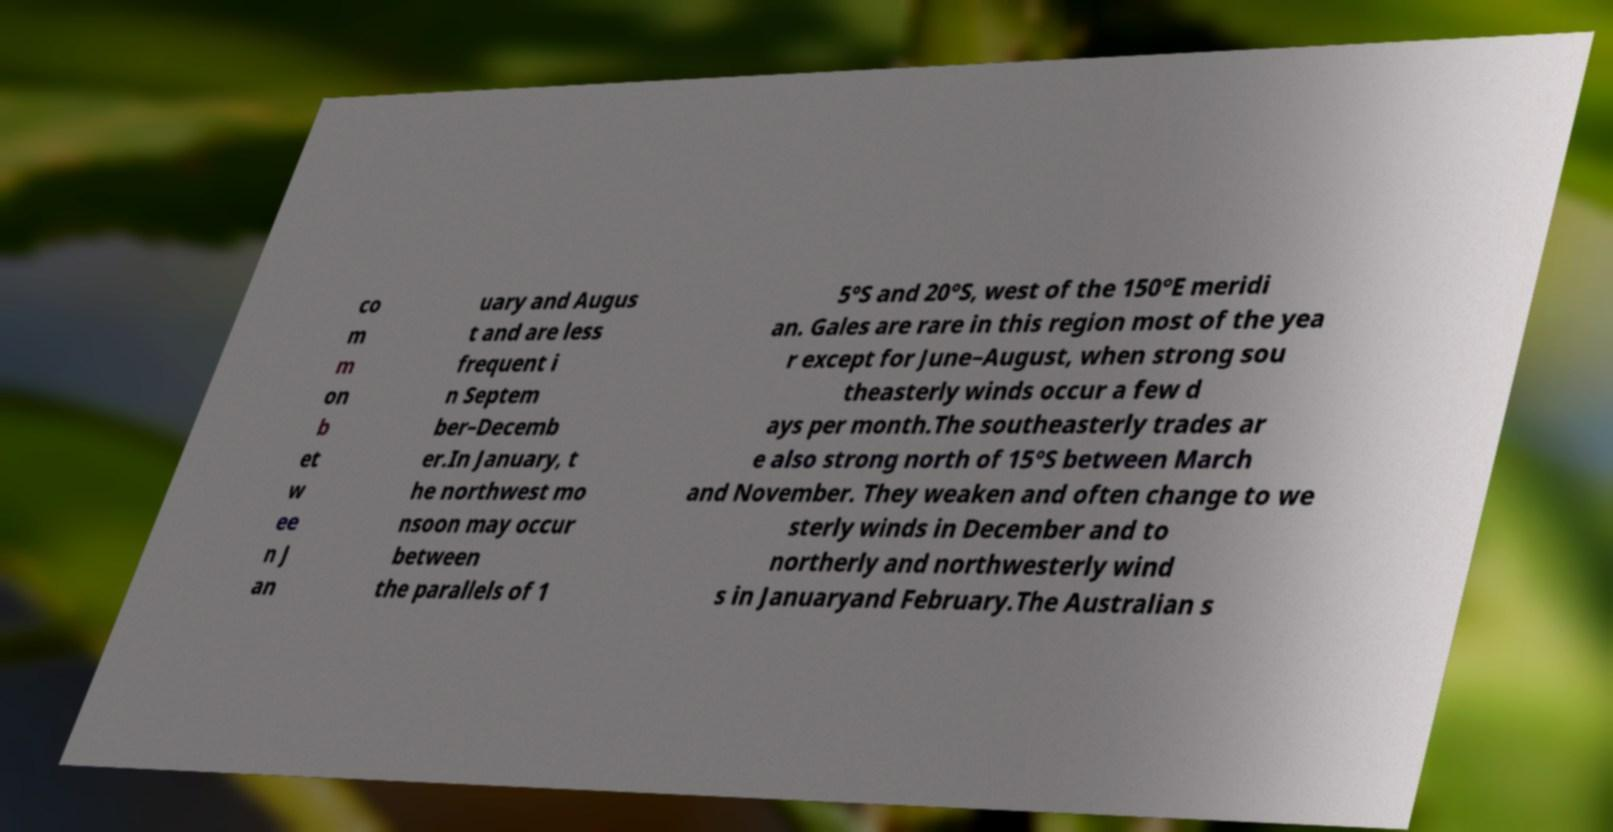Can you accurately transcribe the text from the provided image for me? co m m on b et w ee n J an uary and Augus t and are less frequent i n Septem ber–Decemb er.In January, t he northwest mo nsoon may occur between the parallels of 1 5°S and 20°S, west of the 150°E meridi an. Gales are rare in this region most of the yea r except for June–August, when strong sou theasterly winds occur a few d ays per month.The southeasterly trades ar e also strong north of 15°S between March and November. They weaken and often change to we sterly winds in December and to northerly and northwesterly wind s in Januaryand February.The Australian s 